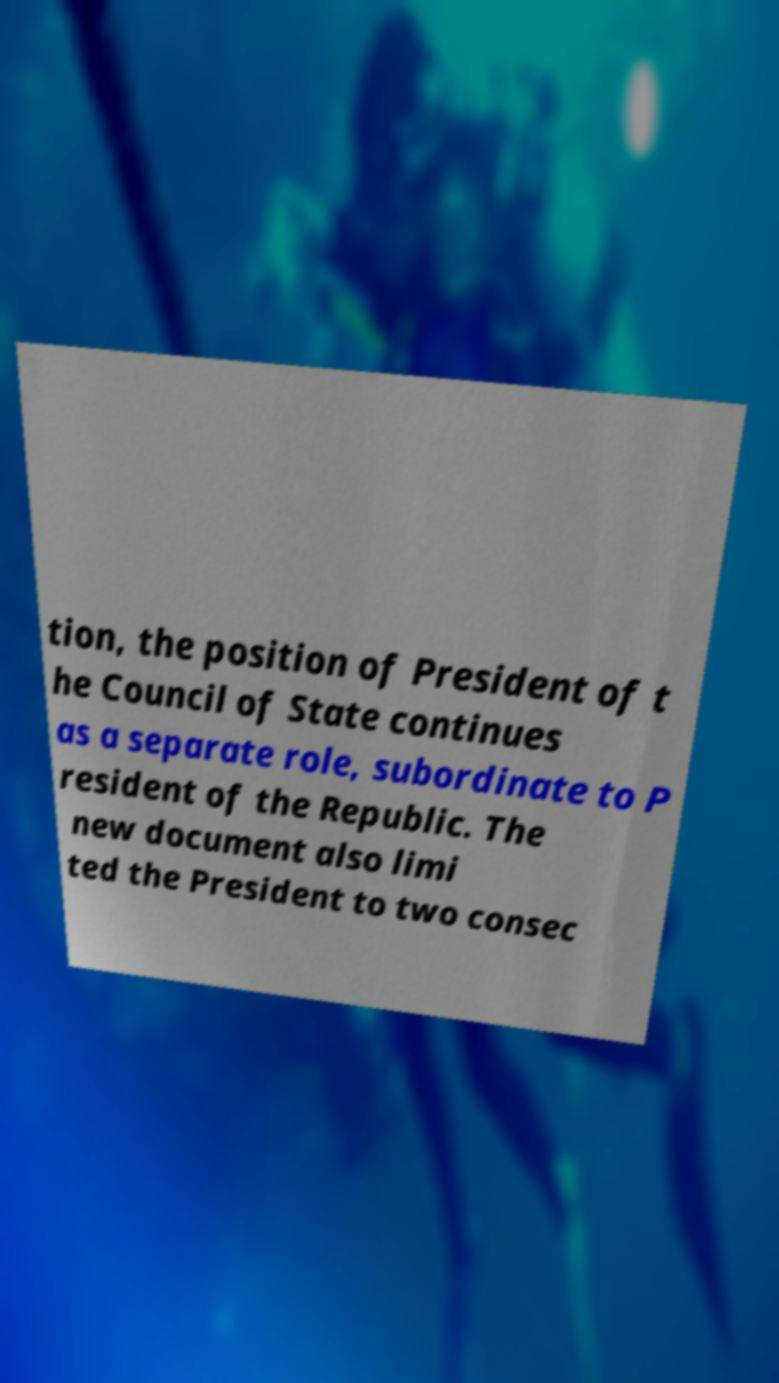Can you read and provide the text displayed in the image?This photo seems to have some interesting text. Can you extract and type it out for me? tion, the position of President of t he Council of State continues as a separate role, subordinate to P resident of the Republic. The new document also limi ted the President to two consec 